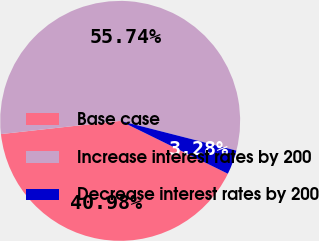Convert chart to OTSL. <chart><loc_0><loc_0><loc_500><loc_500><pie_chart><fcel>Base case<fcel>Increase interest rates by 200<fcel>Decrease interest rates by 200<nl><fcel>40.98%<fcel>55.74%<fcel>3.28%<nl></chart> 